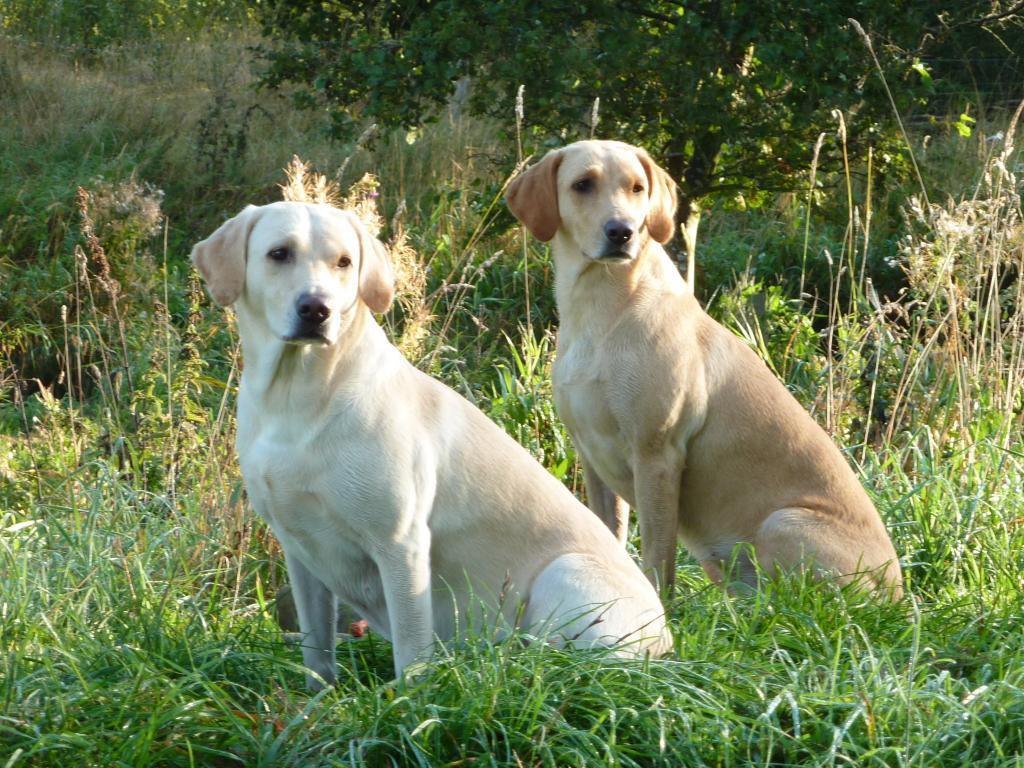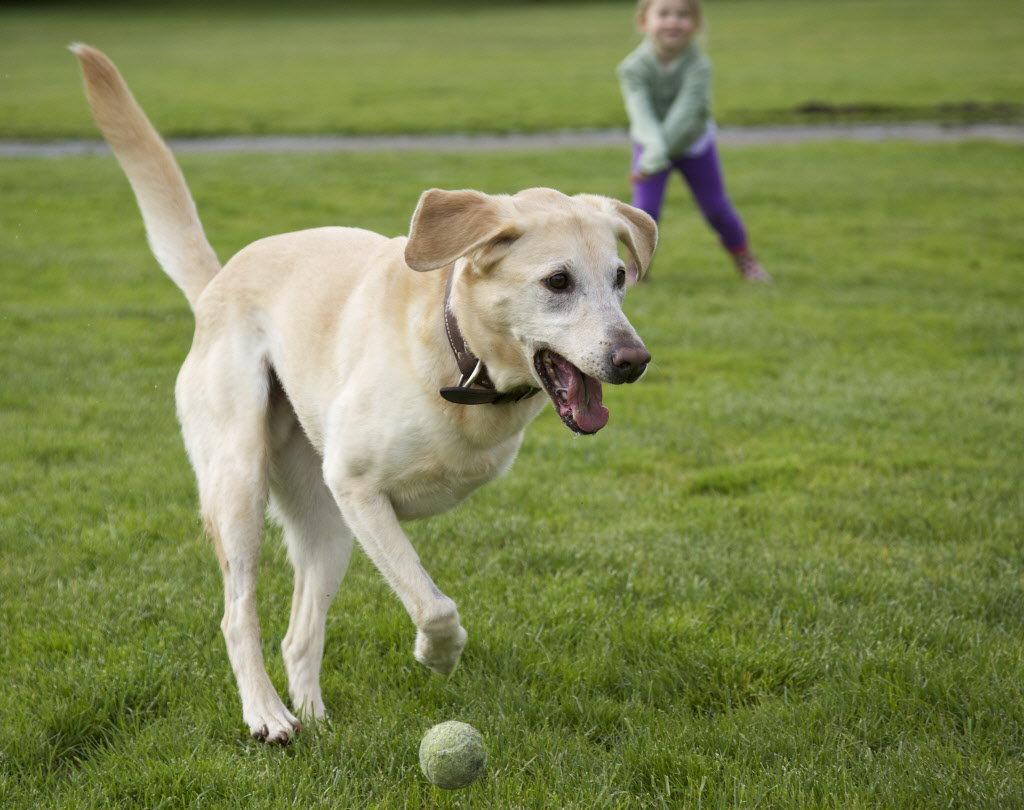The first image is the image on the left, the second image is the image on the right. Evaluate the accuracy of this statement regarding the images: "One of the dogs is missing a front leg.". Is it true? Answer yes or no. Yes. The first image is the image on the left, the second image is the image on the right. For the images shown, is this caption "One image features one dog that is missing a front limb, and the other image contains at least twice as many dogs." true? Answer yes or no. Yes. 